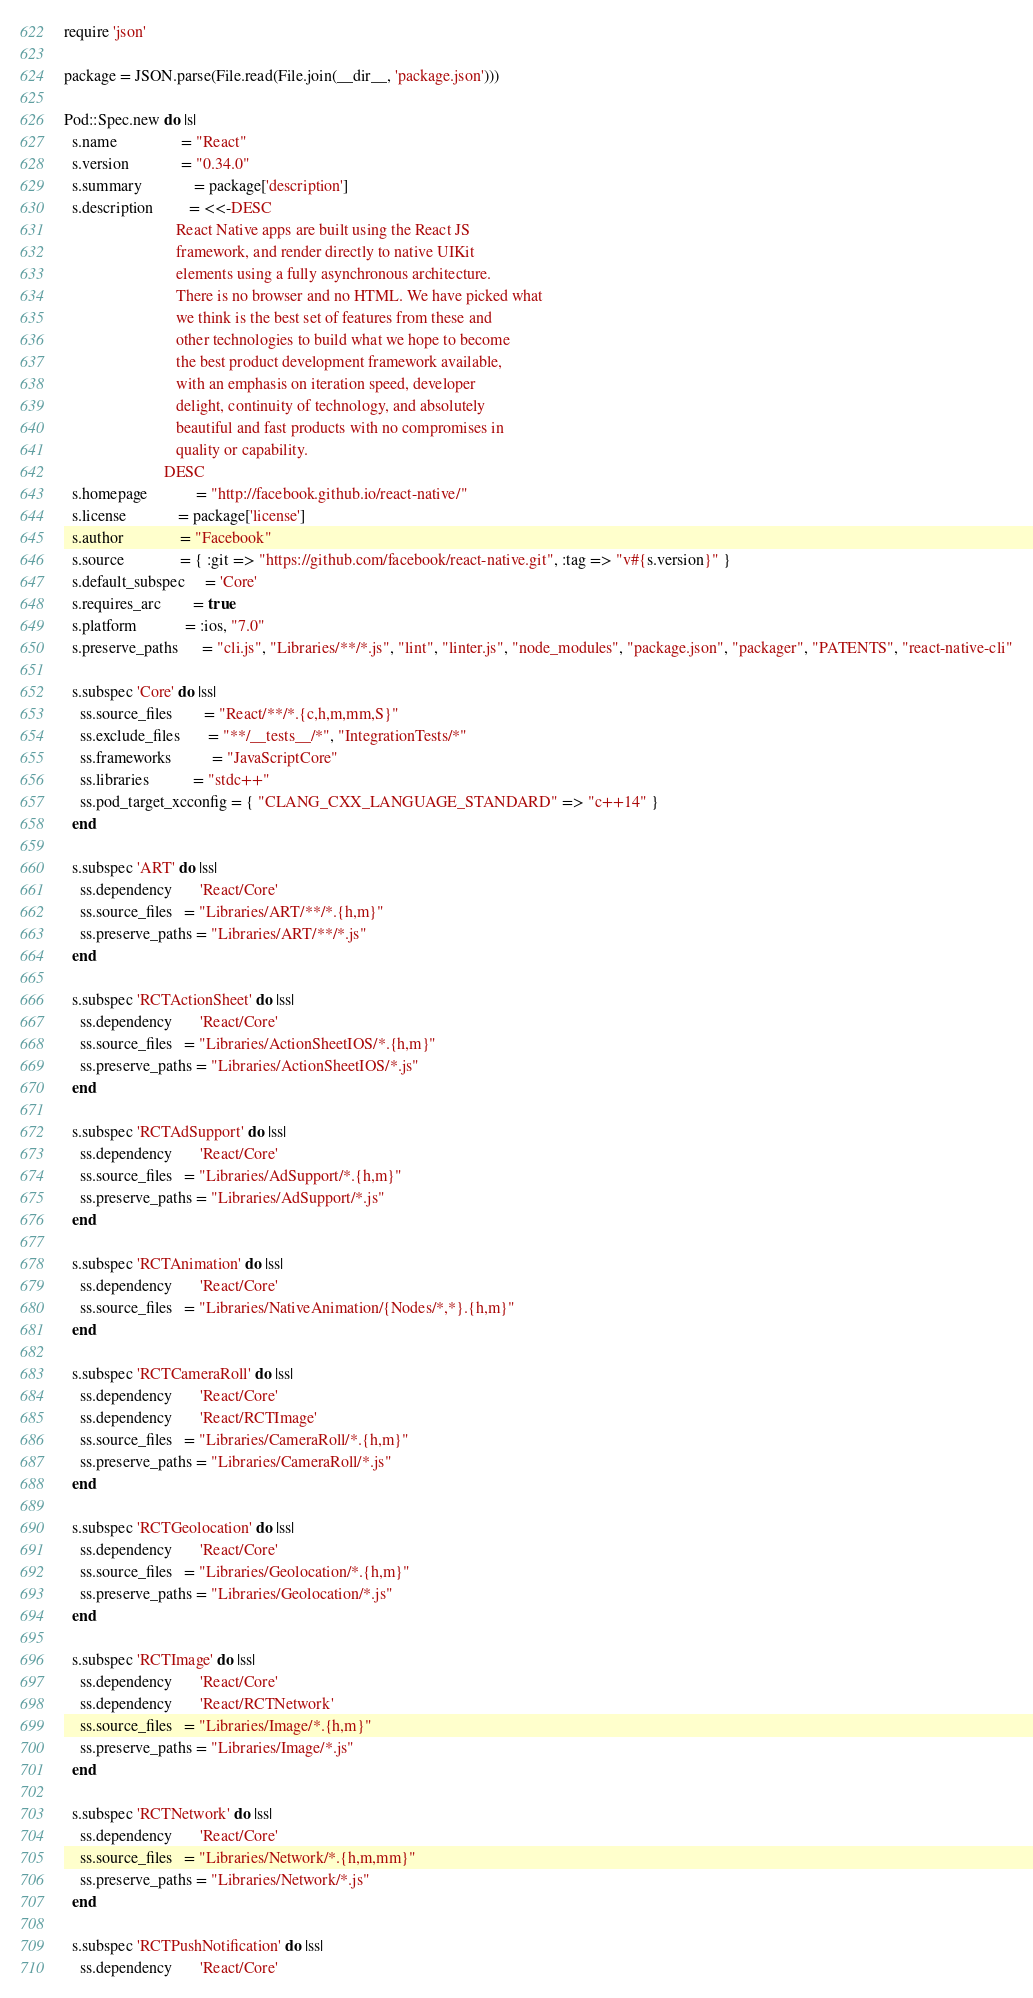Convert code to text. <code><loc_0><loc_0><loc_500><loc_500><_Ruby_>require 'json'

package = JSON.parse(File.read(File.join(__dir__, 'package.json')))

Pod::Spec.new do |s|
  s.name                = "React"
  s.version             = "0.34.0"
  s.summary             = package['description']
  s.description         = <<-DESC
                            React Native apps are built using the React JS
                            framework, and render directly to native UIKit
                            elements using a fully asynchronous architecture.
                            There is no browser and no HTML. We have picked what
                            we think is the best set of features from these and
                            other technologies to build what we hope to become
                            the best product development framework available,
                            with an emphasis on iteration speed, developer
                            delight, continuity of technology, and absolutely
                            beautiful and fast products with no compromises in
                            quality or capability.
                         DESC
  s.homepage            = "http://facebook.github.io/react-native/"
  s.license             = package['license']
  s.author              = "Facebook"
  s.source              = { :git => "https://github.com/facebook/react-native.git", :tag => "v#{s.version}" }
  s.default_subspec     = 'Core'
  s.requires_arc        = true
  s.platform            = :ios, "7.0"
  s.preserve_paths      = "cli.js", "Libraries/**/*.js", "lint", "linter.js", "node_modules", "package.json", "packager", "PATENTS", "react-native-cli"

  s.subspec 'Core' do |ss|
    ss.source_files        = "React/**/*.{c,h,m,mm,S}"
    ss.exclude_files       = "**/__tests__/*", "IntegrationTests/*"
    ss.frameworks          = "JavaScriptCore"
    ss.libraries           = "stdc++"
    ss.pod_target_xcconfig = { "CLANG_CXX_LANGUAGE_STANDARD" => "c++14" }
  end

  s.subspec 'ART' do |ss|
    ss.dependency       'React/Core'
    ss.source_files   = "Libraries/ART/**/*.{h,m}"
    ss.preserve_paths = "Libraries/ART/**/*.js"
  end

  s.subspec 'RCTActionSheet' do |ss|
    ss.dependency       'React/Core'
    ss.source_files   = "Libraries/ActionSheetIOS/*.{h,m}"
    ss.preserve_paths = "Libraries/ActionSheetIOS/*.js"
  end

  s.subspec 'RCTAdSupport' do |ss|
    ss.dependency       'React/Core'
    ss.source_files   = "Libraries/AdSupport/*.{h,m}"
    ss.preserve_paths = "Libraries/AdSupport/*.js"
  end

  s.subspec 'RCTAnimation' do |ss|
    ss.dependency       'React/Core'
    ss.source_files   = "Libraries/NativeAnimation/{Nodes/*,*}.{h,m}"
  end

  s.subspec 'RCTCameraRoll' do |ss|
    ss.dependency       'React/Core'
    ss.dependency       'React/RCTImage'
    ss.source_files   = "Libraries/CameraRoll/*.{h,m}"
    ss.preserve_paths = "Libraries/CameraRoll/*.js"
  end

  s.subspec 'RCTGeolocation' do |ss|
    ss.dependency       'React/Core'
    ss.source_files   = "Libraries/Geolocation/*.{h,m}"
    ss.preserve_paths = "Libraries/Geolocation/*.js"
  end

  s.subspec 'RCTImage' do |ss|
    ss.dependency       'React/Core'
    ss.dependency       'React/RCTNetwork'
    ss.source_files   = "Libraries/Image/*.{h,m}"
    ss.preserve_paths = "Libraries/Image/*.js"
  end

  s.subspec 'RCTNetwork' do |ss|
    ss.dependency       'React/Core'
    ss.source_files   = "Libraries/Network/*.{h,m,mm}"
    ss.preserve_paths = "Libraries/Network/*.js"
  end

  s.subspec 'RCTPushNotification' do |ss|
    ss.dependency       'React/Core'</code> 